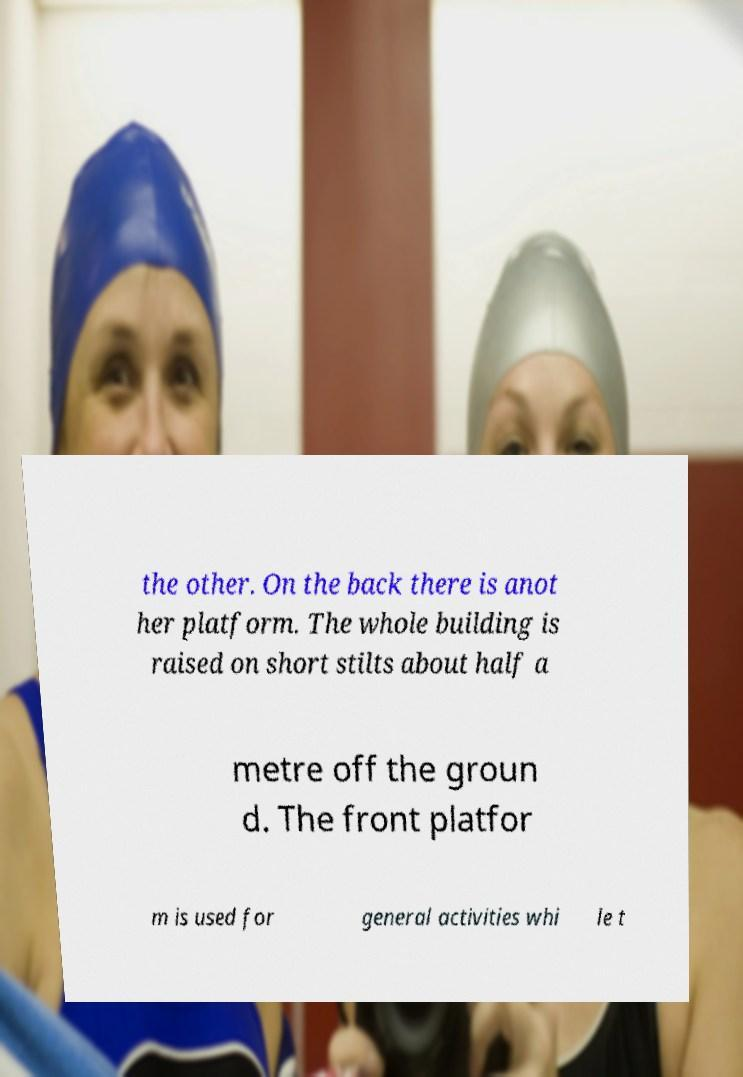Can you read and provide the text displayed in the image?This photo seems to have some interesting text. Can you extract and type it out for me? the other. On the back there is anot her platform. The whole building is raised on short stilts about half a metre off the groun d. The front platfor m is used for general activities whi le t 